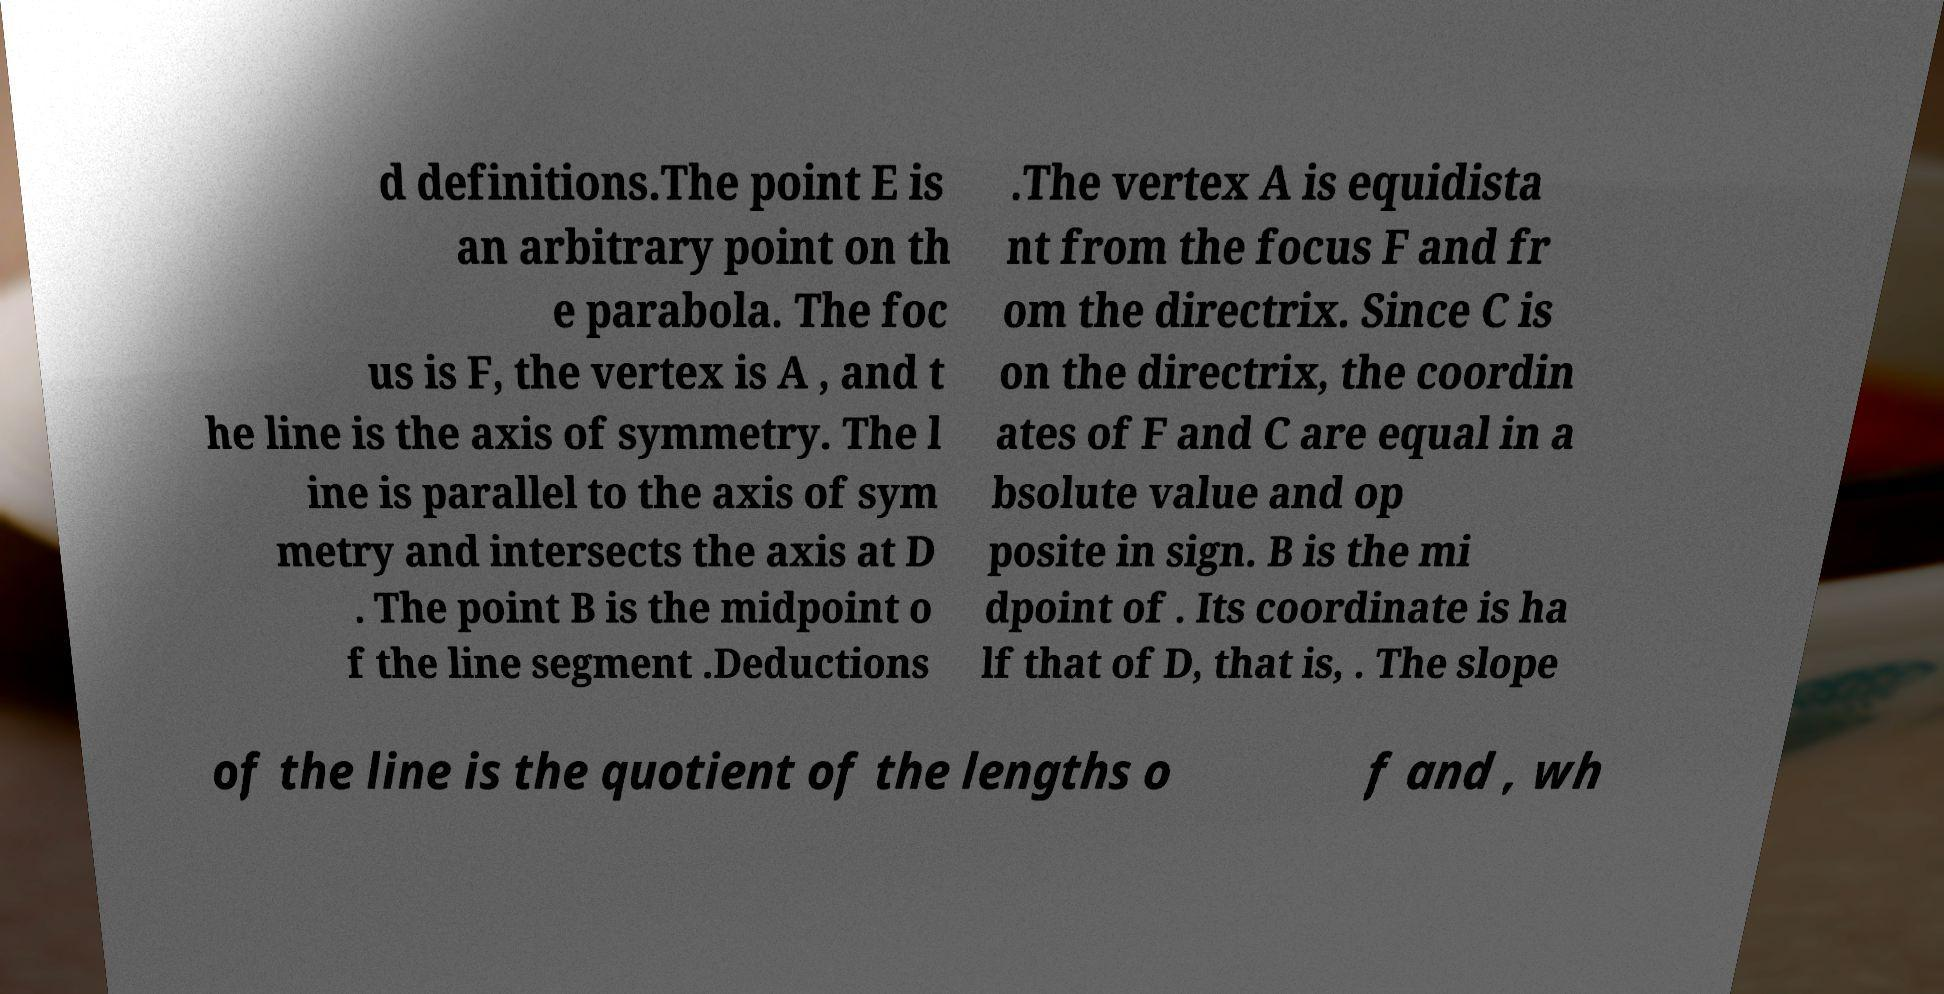Please read and relay the text visible in this image. What does it say? d definitions.The point E is an arbitrary point on th e parabola. The foc us is F, the vertex is A , and t he line is the axis of symmetry. The l ine is parallel to the axis of sym metry and intersects the axis at D . The point B is the midpoint o f the line segment .Deductions .The vertex A is equidista nt from the focus F and fr om the directrix. Since C is on the directrix, the coordin ates of F and C are equal in a bsolute value and op posite in sign. B is the mi dpoint of . Its coordinate is ha lf that of D, that is, . The slope of the line is the quotient of the lengths o f and , wh 